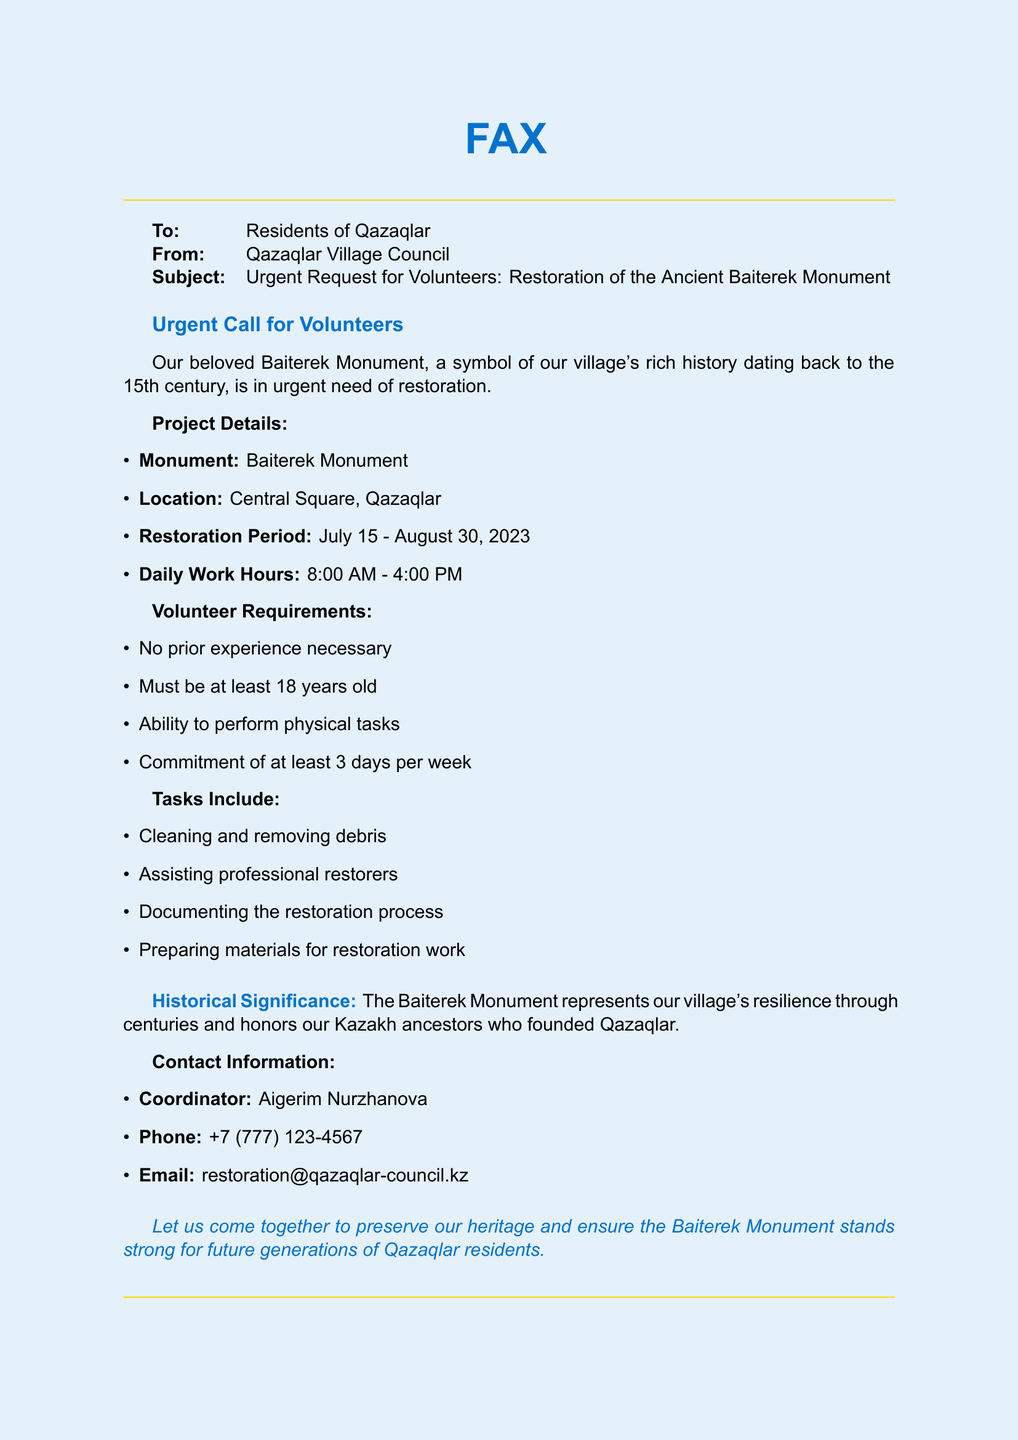What is the monument that needs restoration? The document mentions the Baiterek Monument as the subject of restoration.
Answer: Baiterek Monument Where is the location of the Baiterek Monument? According to the document, the location is specified as Central Square, Qazaqlar.
Answer: Central Square, Qazaqlar What is the restoration period for the monument? The document states the restoration period is from July 15 to August 30, 2023.
Answer: July 15 - August 30, 2023 How many days a week must volunteers commit? The document specifies that volunteers must commit to at least 3 days per week.
Answer: 3 days Who is the coordinator for the restoration project? The document identifies Aigerim Nurzhanova as the coordinator for volunteers.
Answer: Aigerim Nurzhanova What tasks will volunteers be performing? The document lists tasks including cleaning, assisting restorers, documenting, and preparing materials.
Answer: Cleaning, assisting restorers, documenting, preparing materials What age must volunteers be at minimum? The document states that volunteers must be at least 18 years old.
Answer: 18 years What is the daily work hour for volunteers? The document indicates that the daily work hours are from 8:00 AM to 4:00 PM.
Answer: 8:00 AM - 4:00 PM 